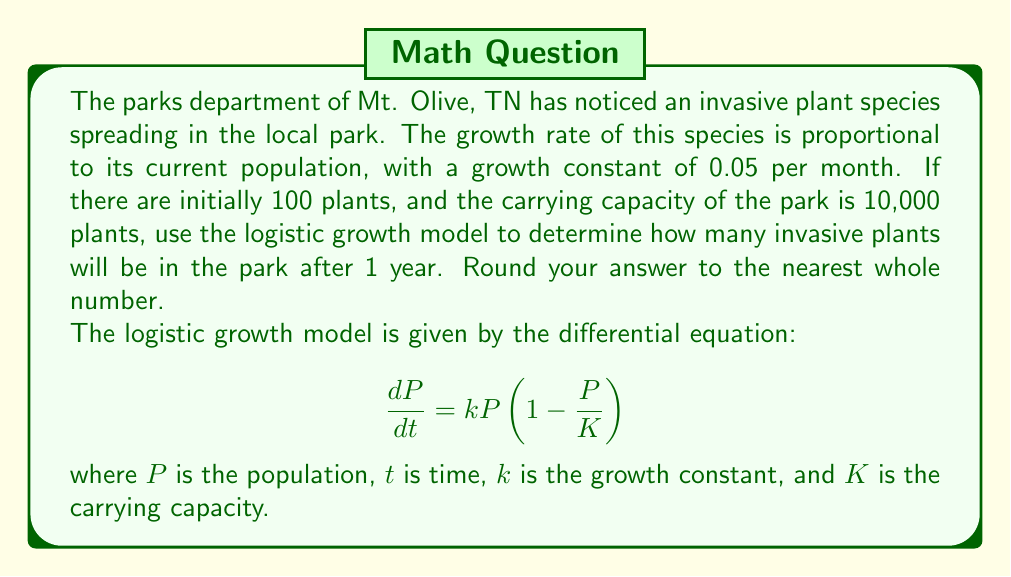Show me your answer to this math problem. To solve this problem, we'll use the logistic growth model, which is appropriate for modeling population dynamics with a carrying capacity.

1) The logistic growth equation's solution is:

   $$P(t) = \frac{K}{1 + (\frac{K}{P_0} - 1)e^{-kt}}$$

   Where:
   $K$ = carrying capacity = 10,000
   $P_0$ = initial population = 100
   $k$ = growth constant = 0.05 per month
   $t$ = time in months = 12 (1 year)

2) Let's substitute these values into the equation:

   $$P(12) = \frac{10000}{1 + (\frac{10000}{100} - 1)e^{-0.05(12)}}$$

3) Simplify:
   $$P(12) = \frac{10000}{1 + (99)e^{-0.6}}$$

4) Calculate $e^{-0.6}$:
   $$e^{-0.6} \approx 0.5488$$

5) Substitute this value:
   $$P(12) = \frac{10000}{1 + (99)(0.5488)} = \frac{10000}{55.3312}$$

6) Calculate the final result:
   $$P(12) \approx 180.7302$$

7) Rounding to the nearest whole number:
   $$P(12) \approx 181$$
Answer: 181 invasive plants 